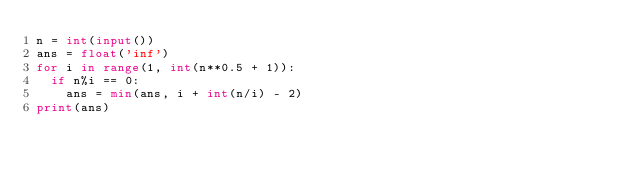Convert code to text. <code><loc_0><loc_0><loc_500><loc_500><_Python_>n = int(input())
ans = float('inf')
for i in range(1, int(n**0.5 + 1)):
  if n%i == 0:
    ans = min(ans, i + int(n/i) - 2)
print(ans)</code> 